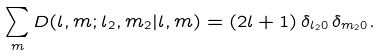<formula> <loc_0><loc_0><loc_500><loc_500>\sum _ { m } D ( l , m ; l _ { 2 } , m _ { 2 } | l , m ) = ( 2 l + 1 ) \, \delta _ { l _ { 2 } 0 } \, \delta _ { m _ { 2 } 0 } .</formula> 